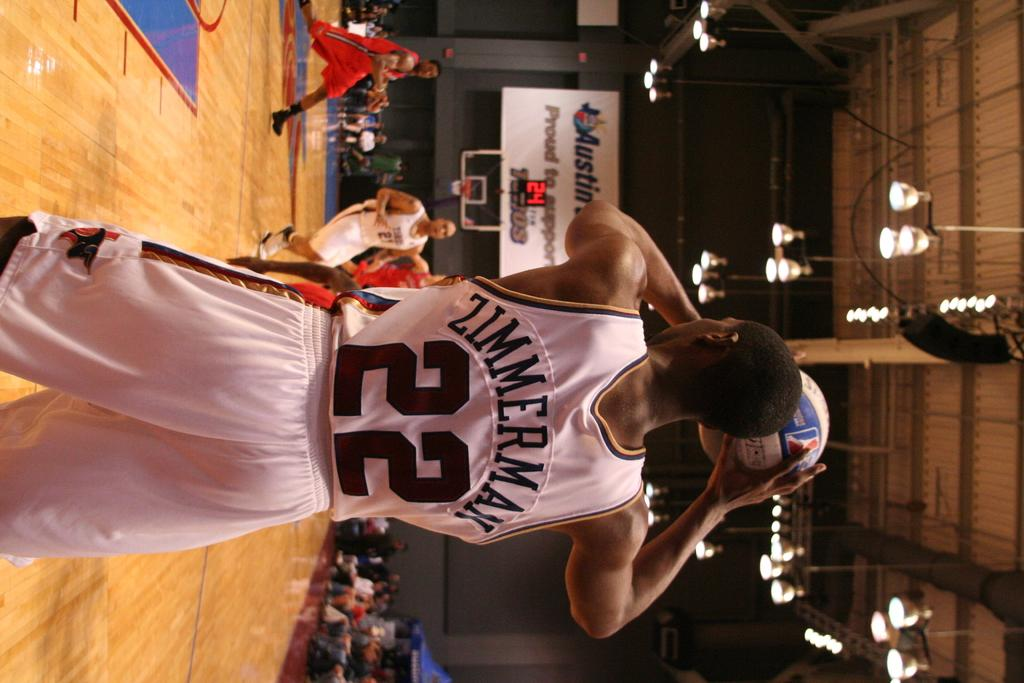<image>
Create a compact narrative representing the image presented. a man in a Zimmerman 22 jersey about to make a basketball shot 